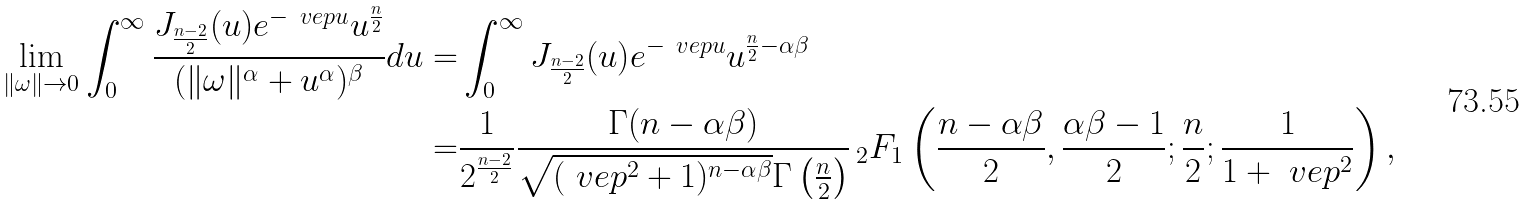Convert formula to latex. <formula><loc_0><loc_0><loc_500><loc_500>\lim _ { \| \omega \| \rightarrow 0 } \int _ { 0 } ^ { \infty } \frac { J _ { \frac { n - 2 } { 2 } } ( u ) e ^ { - \ v e p u } u ^ { \frac { n } { 2 } } } { ( \| \omega \| ^ { \alpha } + u ^ { \alpha } ) ^ { \beta } } d u = & \int _ { 0 } ^ { \infty } J _ { \frac { n - 2 } { 2 } } ( u ) e ^ { - \ v e p u } u ^ { \frac { n } { 2 } - \alpha \beta } \\ = & \frac { 1 } { 2 ^ { \frac { n - 2 } { 2 } } } \frac { \Gamma ( n - \alpha \beta ) } { \sqrt { ( \ v e p ^ { 2 } + 1 ) ^ { n - \alpha \beta } } \Gamma \left ( \frac { n } { 2 } \right ) } \, _ { 2 } F _ { 1 } \left ( \frac { n - \alpha \beta } { 2 } , \frac { \alpha \beta - 1 } { 2 } ; \frac { n } { 2 } ; \frac { 1 } { 1 + \ v e p ^ { 2 } } \right ) ,</formula> 